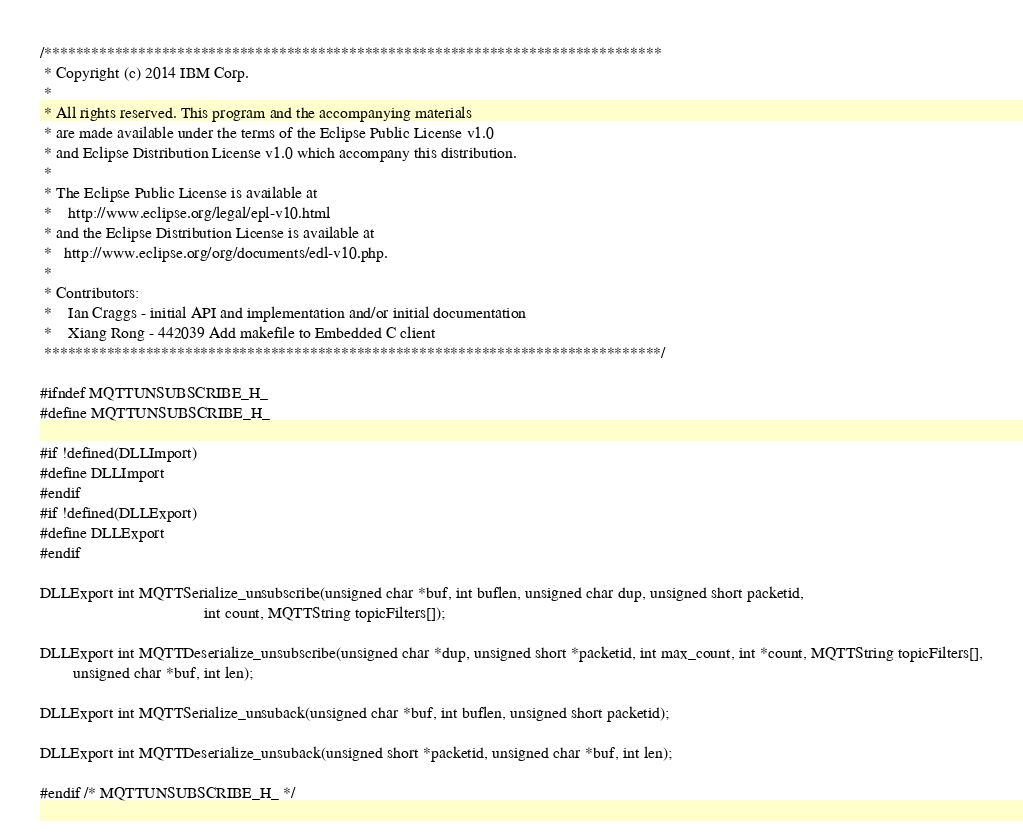Convert code to text. <code><loc_0><loc_0><loc_500><loc_500><_C_>/*******************************************************************************
 * Copyright (c) 2014 IBM Corp.
 *
 * All rights reserved. This program and the accompanying materials
 * are made available under the terms of the Eclipse Public License v1.0
 * and Eclipse Distribution License v1.0 which accompany this distribution.
 *
 * The Eclipse Public License is available at
 *    http://www.eclipse.org/legal/epl-v10.html
 * and the Eclipse Distribution License is available at
 *   http://www.eclipse.org/org/documents/edl-v10.php.
 *
 * Contributors:
 *    Ian Craggs - initial API and implementation and/or initial documentation
 *    Xiang Rong - 442039 Add makefile to Embedded C client
 *******************************************************************************/

#ifndef MQTTUNSUBSCRIBE_H_
#define MQTTUNSUBSCRIBE_H_

#if !defined(DLLImport)
#define DLLImport
#endif
#if !defined(DLLExport)
#define DLLExport
#endif

DLLExport int MQTTSerialize_unsubscribe(unsigned char *buf, int buflen, unsigned char dup, unsigned short packetid,
                                        int count, MQTTString topicFilters[]);

DLLExport int MQTTDeserialize_unsubscribe(unsigned char *dup, unsigned short *packetid, int max_count, int *count, MQTTString topicFilters[],
        unsigned char *buf, int len);

DLLExport int MQTTSerialize_unsuback(unsigned char *buf, int buflen, unsigned short packetid);

DLLExport int MQTTDeserialize_unsuback(unsigned short *packetid, unsigned char *buf, int len);

#endif /* MQTTUNSUBSCRIBE_H_ */
</code> 